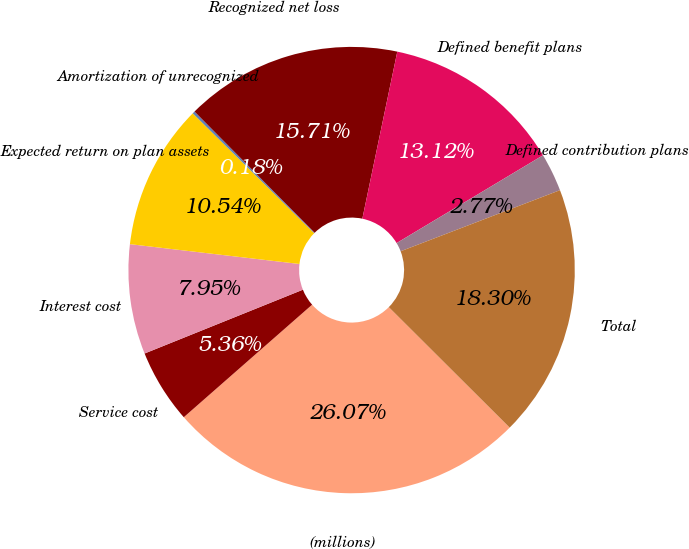Convert chart to OTSL. <chart><loc_0><loc_0><loc_500><loc_500><pie_chart><fcel>(millions)<fcel>Service cost<fcel>Interest cost<fcel>Expected return on plan assets<fcel>Amortization of unrecognized<fcel>Recognized net loss<fcel>Defined benefit plans<fcel>Defined contribution plans<fcel>Total<nl><fcel>26.07%<fcel>5.36%<fcel>7.95%<fcel>10.54%<fcel>0.18%<fcel>15.71%<fcel>13.12%<fcel>2.77%<fcel>18.3%<nl></chart> 